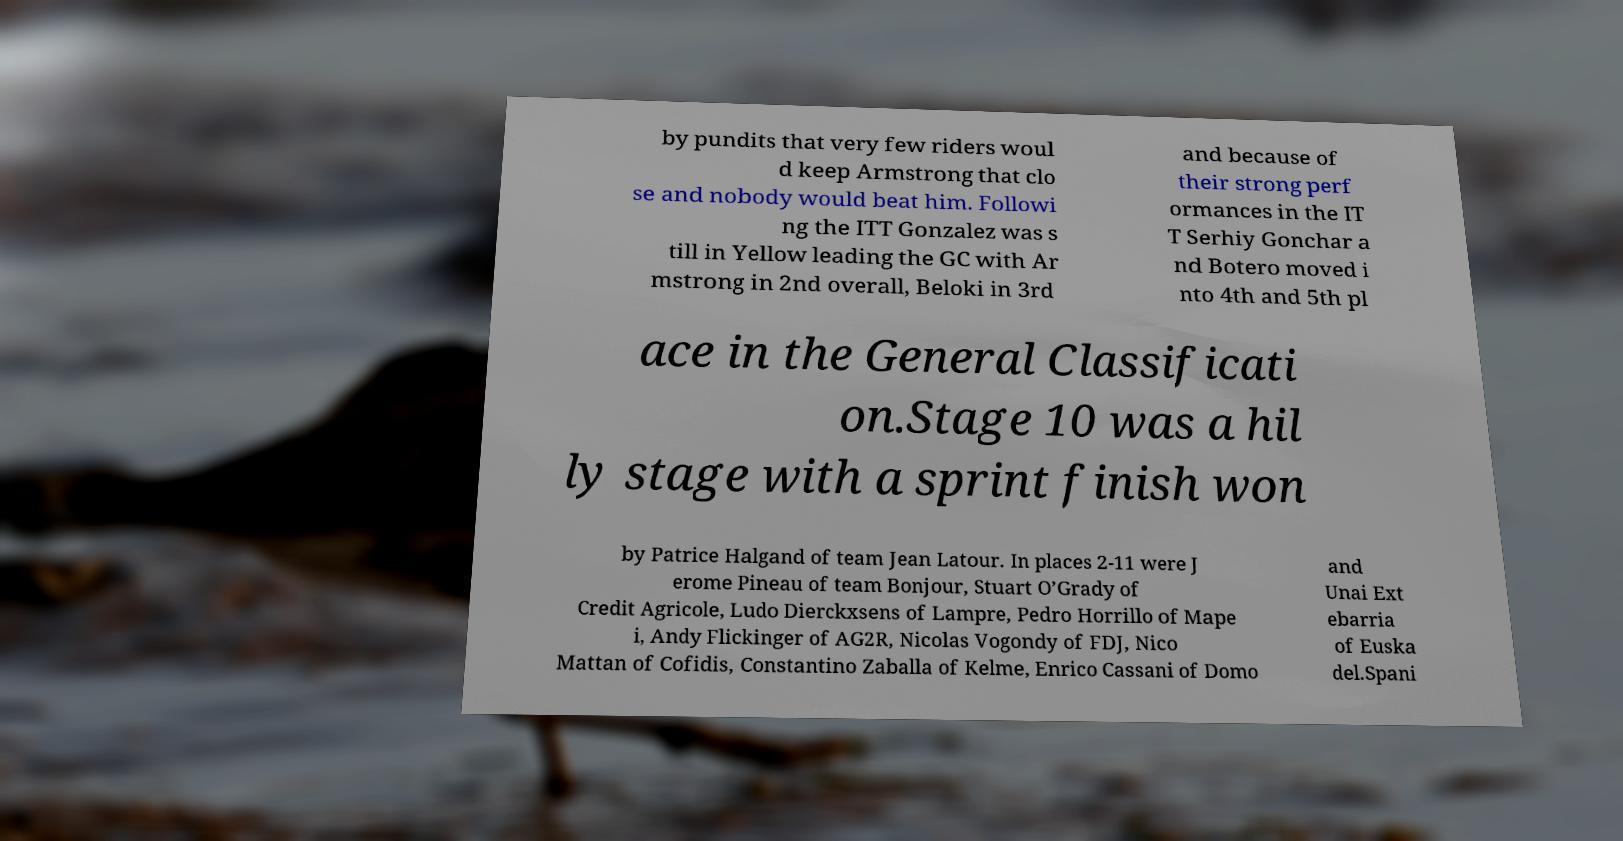Please identify and transcribe the text found in this image. by pundits that very few riders woul d keep Armstrong that clo se and nobody would beat him. Followi ng the ITT Gonzalez was s till in Yellow leading the GC with Ar mstrong in 2nd overall, Beloki in 3rd and because of their strong perf ormances in the IT T Serhiy Gonchar a nd Botero moved i nto 4th and 5th pl ace in the General Classificati on.Stage 10 was a hil ly stage with a sprint finish won by Patrice Halgand of team Jean Latour. In places 2-11 were J erome Pineau of team Bonjour, Stuart O’Grady of Credit Agricole, Ludo Dierckxsens of Lampre, Pedro Horrillo of Mape i, Andy Flickinger of AG2R, Nicolas Vogondy of FDJ, Nico Mattan of Cofidis, Constantino Zaballa of Kelme, Enrico Cassani of Domo and Unai Ext ebarria of Euska del.Spani 